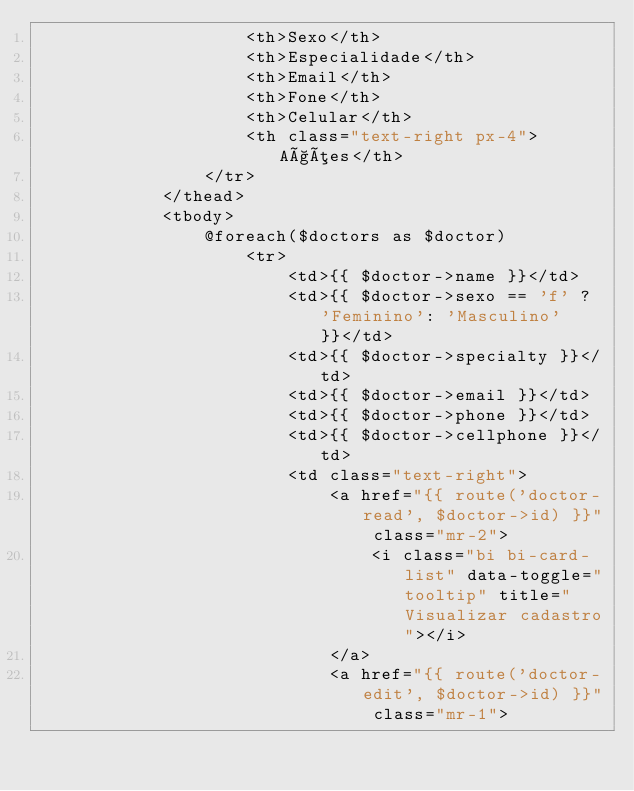<code> <loc_0><loc_0><loc_500><loc_500><_PHP_>                    <th>Sexo</th>
                    <th>Especialidade</th>
                    <th>Email</th>
                    <th>Fone</th>
                    <th>Celular</th>
                    <th class="text-right px-4">Ações</th>
                </tr>
            </thead>
            <tbody>
                @foreach($doctors as $doctor)
                    <tr>
                        <td>{{ $doctor->name }}</td>
                        <td>{{ $doctor->sexo == 'f' ? 'Feminino': 'Masculino' }}</td>
                        <td>{{ $doctor->specialty }}</td>
                        <td>{{ $doctor->email }}</td>
                        <td>{{ $doctor->phone }}</td>
                        <td>{{ $doctor->cellphone }}</td>
                        <td class="text-right">
                            <a href="{{ route('doctor-read', $doctor->id) }}" class="mr-2">
                                <i class="bi bi-card-list" data-toggle="tooltip" title="Visualizar cadastro"></i>
                            </a>
                            <a href="{{ route('doctor-edit', $doctor->id) }}" class="mr-1"></code> 